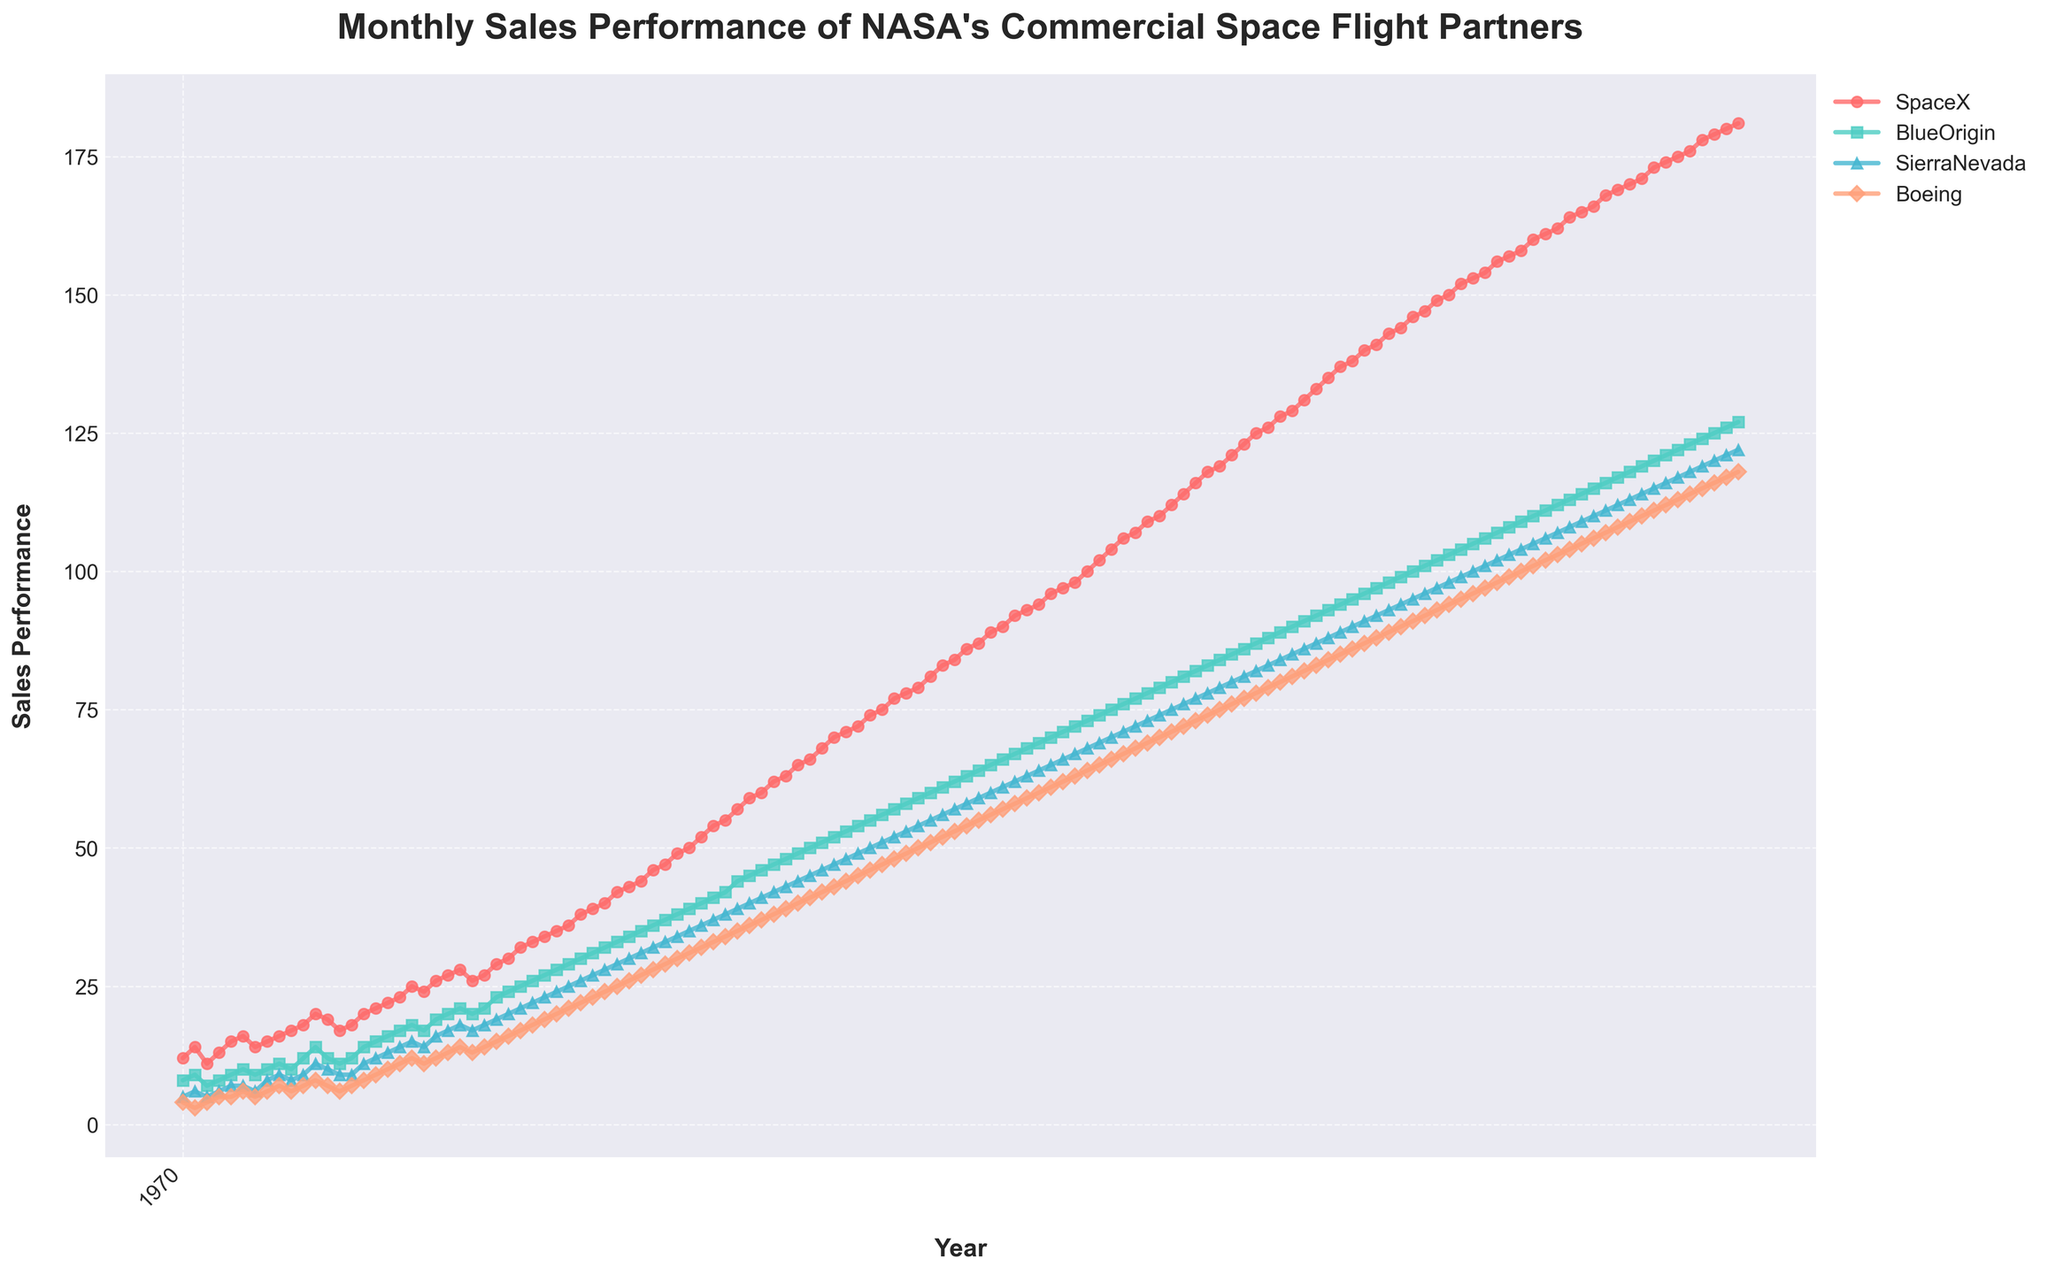What is the title of the figure? The title of the figure is typically shown at the top of the plot. Here, it reads "Monthly Sales Performance of NASA's Commercial Space Flight Partners".
Answer: Monthly Sales Performance of NASA's Commercial Space Flight Partners How many companies' sales performances are plotted? By inspecting the legend or the number of distinct lines in the plot, we can see there are four companies represented.
Answer: Four What colors are used to represent SpaceX and BlueOrigin? The plot uses different colors for each company, with SpaceX usually assigned a red hue and BlueOrigin a teal or light blue hue.
Answer: Red for SpaceX and Teal for BlueOrigin Which company had the highest sales performance in January 2023? By examining the point corresponding to January 2023 on the x-axis and observing the values for each company at that point, it is evident that SpaceX had the highest sales.
Answer: SpaceX Compare the sales performance of BlueOrigin with Boeing in December 2022. Which company had higher sales? In December 2022, check the two lines corresponding to BlueOrigin and Boeing. The line for BlueOrigin will be higher on the y-axis than Boeing in this month.
Answer: BlueOrigin What is the general trend in sales performance for SpaceX over the decade? By looking at the line representing SpaceX from the start (2013) to the end (2023), one can observe a consistent upward trend.
Answer: Upward Calculate the average sales performance for SierraNevada in 2020. Summing up SierraNevada's sales for each month in 2020 and then dividing by 12 will give the average. The sales for SierraNevada in 2020 are: (77 + 78 + 79 + 80 + 81 + 82 + 83 + 84 + 85 + 86 + 87 + 88) which sums to 1000, divided by 12.
Answer: 83.33 Which company had the most fluctuation in sales over the decade? To identify fluctuations, one has to visually assess the variability in the sales line. SpaceX has the most significant changes and growth, indicating the highest fluctuation.
Answer: SpaceX What was the sales difference between SpaceX and BlueOrigin in June 2019? Find the sales for SpaceX and BlueOrigin in June 2019 by looking at the visual markers. SpaceX had 104 and BlueOrigin had 75, so the difference is 104 - 75.
Answer: 29 Was there any year where Boeing’s sales performance overtook SierraNevada? By comparing the lines of Boeing and SierraNevada over the years, we see that Boeing consistently had lower sales until the end of the decade, where it only closed the gap but never overtook.
Answer: No 